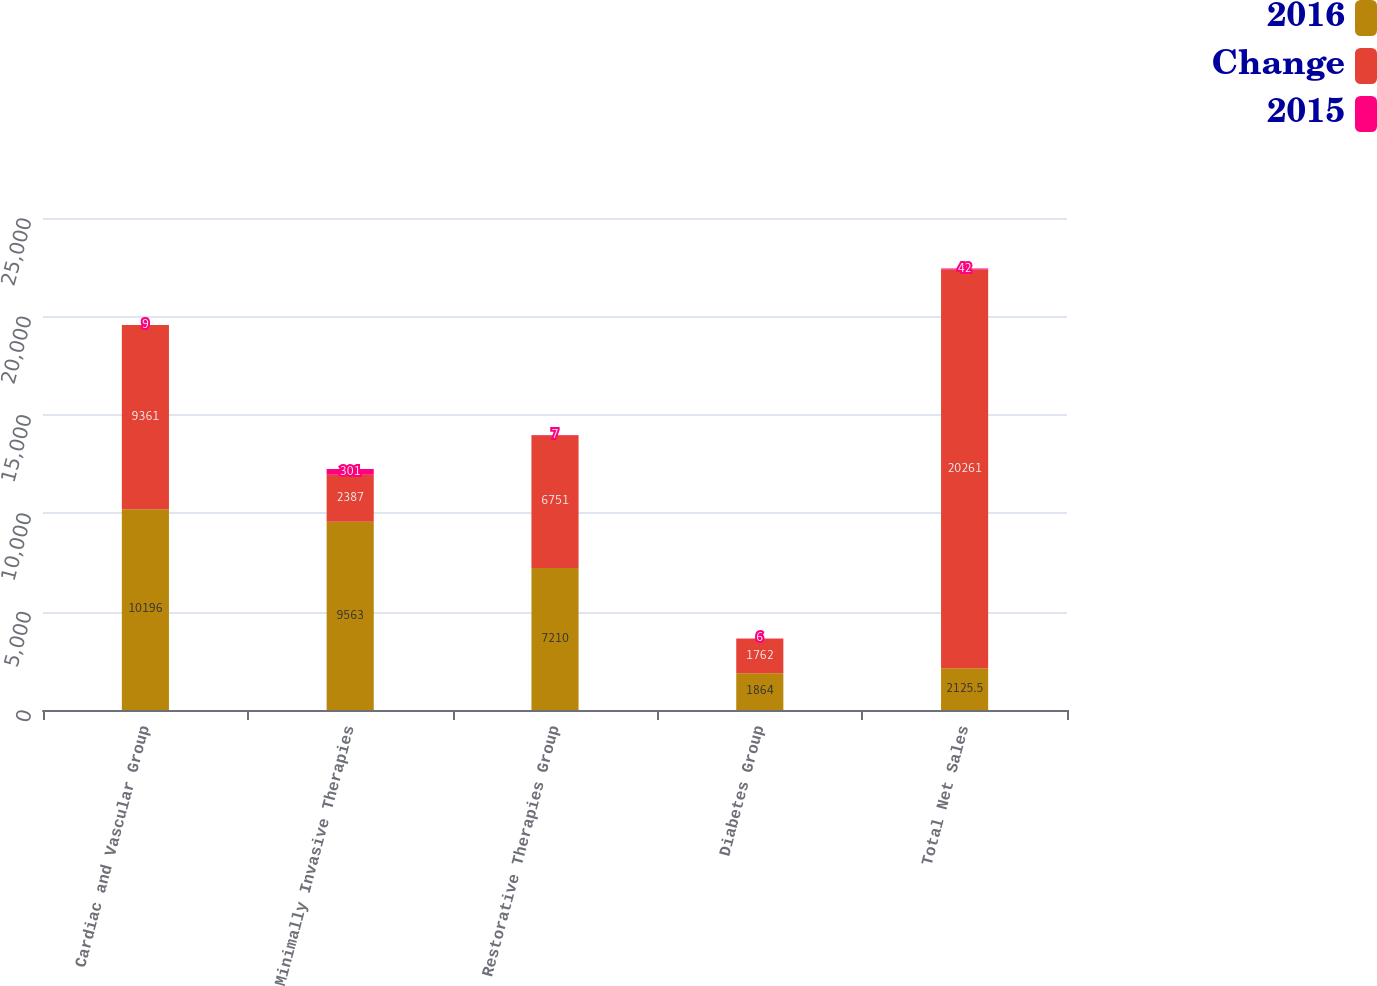<chart> <loc_0><loc_0><loc_500><loc_500><stacked_bar_chart><ecel><fcel>Cardiac and Vascular Group<fcel>Minimally Invasive Therapies<fcel>Restorative Therapies Group<fcel>Diabetes Group<fcel>Total Net Sales<nl><fcel>2016<fcel>10196<fcel>9563<fcel>7210<fcel>1864<fcel>2125.5<nl><fcel>Change<fcel>9361<fcel>2387<fcel>6751<fcel>1762<fcel>20261<nl><fcel>2015<fcel>9<fcel>301<fcel>7<fcel>6<fcel>42<nl></chart> 